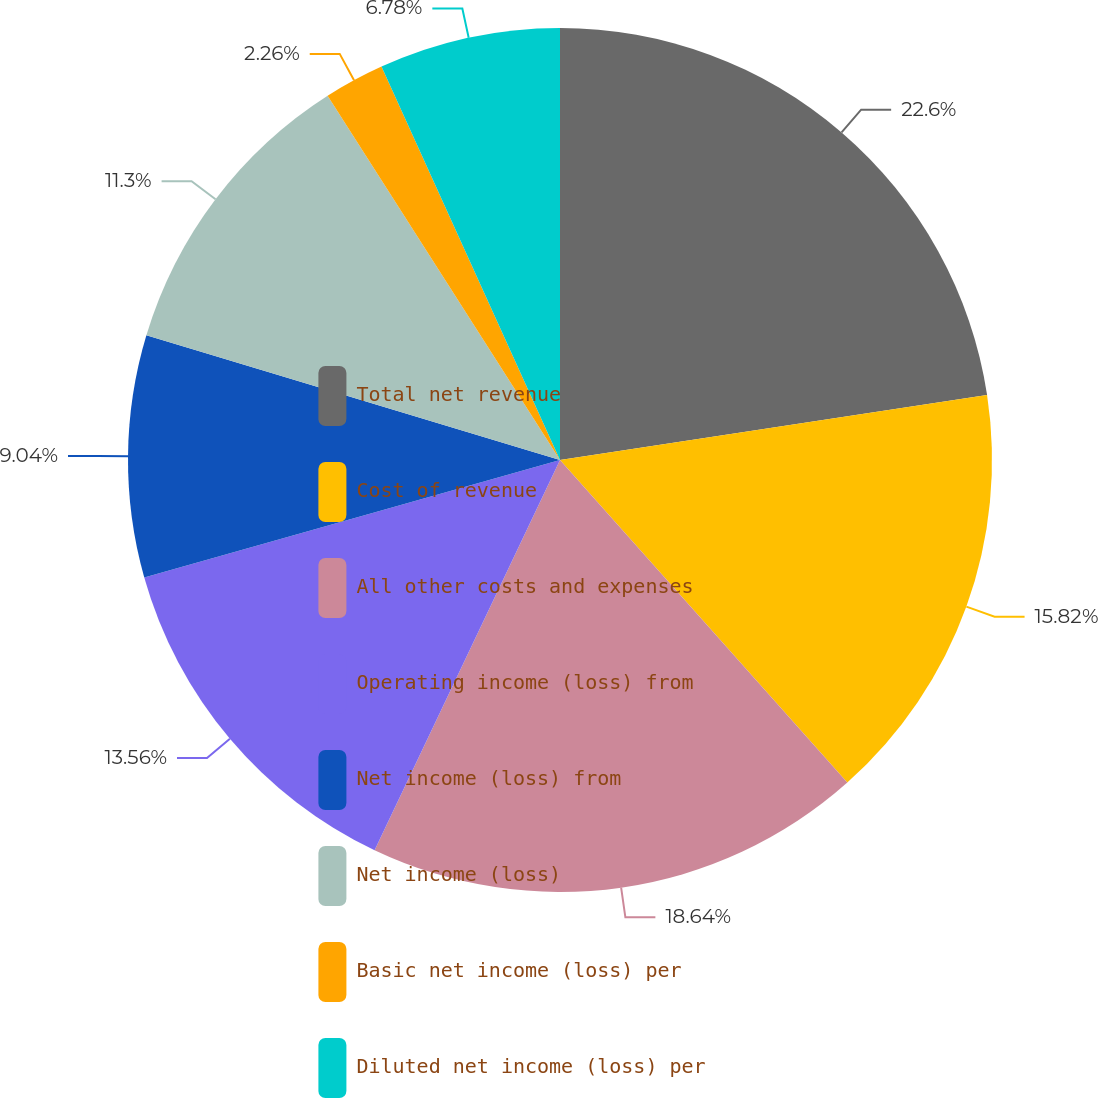<chart> <loc_0><loc_0><loc_500><loc_500><pie_chart><fcel>Total net revenue<fcel>Cost of revenue<fcel>All other costs and expenses<fcel>Operating income (loss) from<fcel>Net income (loss) from<fcel>Net income (loss)<fcel>Basic net income (loss) per<fcel>Diluted net income (loss) per<nl><fcel>22.6%<fcel>15.82%<fcel>18.64%<fcel>13.56%<fcel>9.04%<fcel>11.3%<fcel>2.26%<fcel>6.78%<nl></chart> 